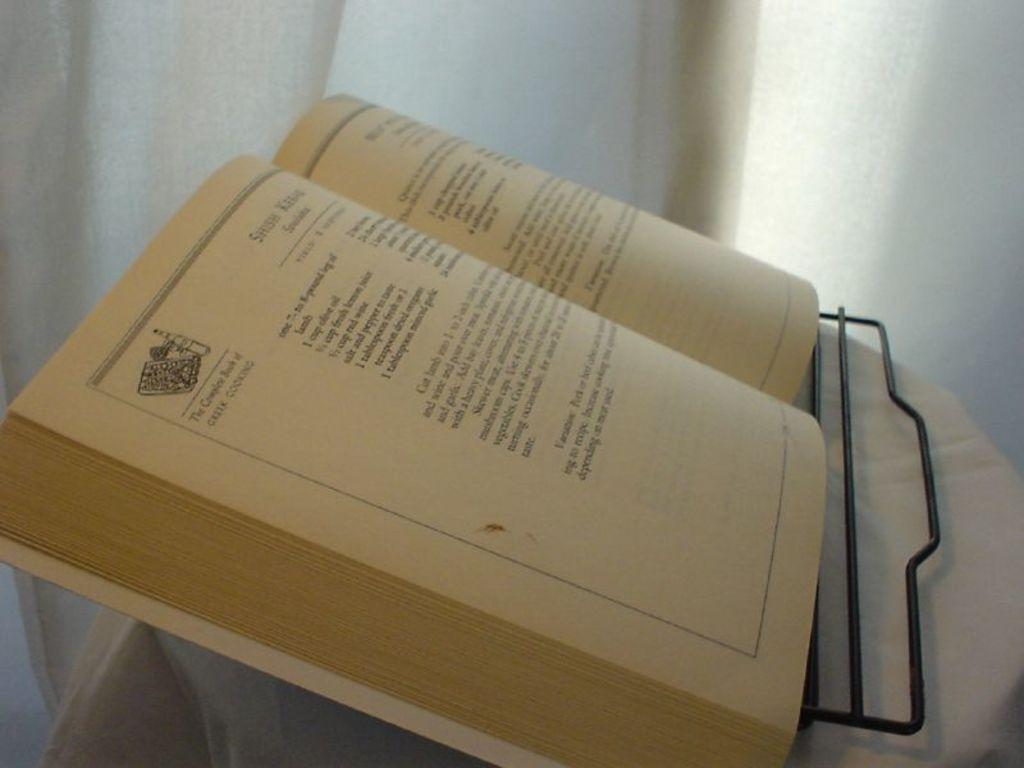<image>
Render a clear and concise summary of the photo. A Greek cooking book lies open on a rack. 